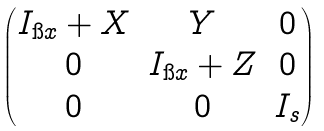<formula> <loc_0><loc_0><loc_500><loc_500>\begin{pmatrix} I _ { \i x } + X & Y & 0 \\ 0 & I _ { \i x } + Z & 0 \\ 0 & 0 & I _ { s } \\ \end{pmatrix}</formula> 